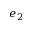Convert formula to latex. <formula><loc_0><loc_0><loc_500><loc_500>e _ { 2 }</formula> 